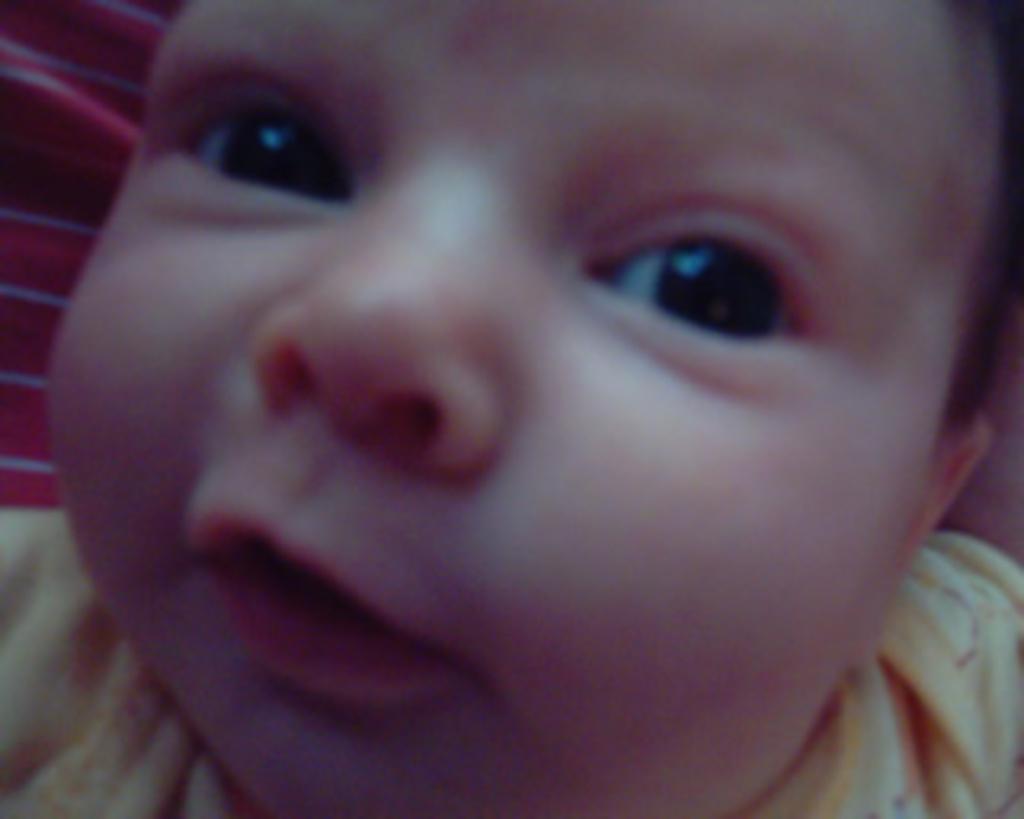Describe this image in one or two sentences. This image consists of a kid wearing a yellow dress. 